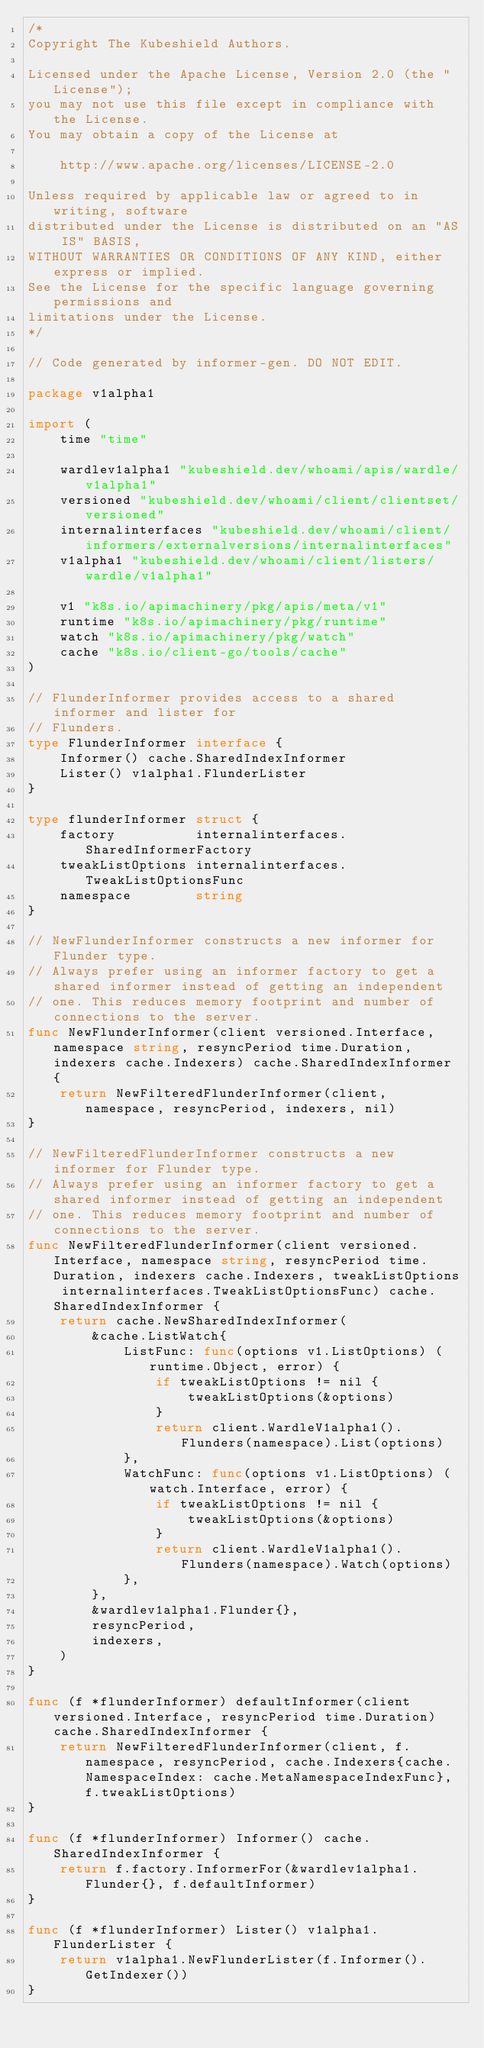<code> <loc_0><loc_0><loc_500><loc_500><_Go_>/*
Copyright The Kubeshield Authors.

Licensed under the Apache License, Version 2.0 (the "License");
you may not use this file except in compliance with the License.
You may obtain a copy of the License at

    http://www.apache.org/licenses/LICENSE-2.0

Unless required by applicable law or agreed to in writing, software
distributed under the License is distributed on an "AS IS" BASIS,
WITHOUT WARRANTIES OR CONDITIONS OF ANY KIND, either express or implied.
See the License for the specific language governing permissions and
limitations under the License.
*/

// Code generated by informer-gen. DO NOT EDIT.

package v1alpha1

import (
	time "time"

	wardlev1alpha1 "kubeshield.dev/whoami/apis/wardle/v1alpha1"
	versioned "kubeshield.dev/whoami/client/clientset/versioned"
	internalinterfaces "kubeshield.dev/whoami/client/informers/externalversions/internalinterfaces"
	v1alpha1 "kubeshield.dev/whoami/client/listers/wardle/v1alpha1"

	v1 "k8s.io/apimachinery/pkg/apis/meta/v1"
	runtime "k8s.io/apimachinery/pkg/runtime"
	watch "k8s.io/apimachinery/pkg/watch"
	cache "k8s.io/client-go/tools/cache"
)

// FlunderInformer provides access to a shared informer and lister for
// Flunders.
type FlunderInformer interface {
	Informer() cache.SharedIndexInformer
	Lister() v1alpha1.FlunderLister
}

type flunderInformer struct {
	factory          internalinterfaces.SharedInformerFactory
	tweakListOptions internalinterfaces.TweakListOptionsFunc
	namespace        string
}

// NewFlunderInformer constructs a new informer for Flunder type.
// Always prefer using an informer factory to get a shared informer instead of getting an independent
// one. This reduces memory footprint and number of connections to the server.
func NewFlunderInformer(client versioned.Interface, namespace string, resyncPeriod time.Duration, indexers cache.Indexers) cache.SharedIndexInformer {
	return NewFilteredFlunderInformer(client, namespace, resyncPeriod, indexers, nil)
}

// NewFilteredFlunderInformer constructs a new informer for Flunder type.
// Always prefer using an informer factory to get a shared informer instead of getting an independent
// one. This reduces memory footprint and number of connections to the server.
func NewFilteredFlunderInformer(client versioned.Interface, namespace string, resyncPeriod time.Duration, indexers cache.Indexers, tweakListOptions internalinterfaces.TweakListOptionsFunc) cache.SharedIndexInformer {
	return cache.NewSharedIndexInformer(
		&cache.ListWatch{
			ListFunc: func(options v1.ListOptions) (runtime.Object, error) {
				if tweakListOptions != nil {
					tweakListOptions(&options)
				}
				return client.WardleV1alpha1().Flunders(namespace).List(options)
			},
			WatchFunc: func(options v1.ListOptions) (watch.Interface, error) {
				if tweakListOptions != nil {
					tweakListOptions(&options)
				}
				return client.WardleV1alpha1().Flunders(namespace).Watch(options)
			},
		},
		&wardlev1alpha1.Flunder{},
		resyncPeriod,
		indexers,
	)
}

func (f *flunderInformer) defaultInformer(client versioned.Interface, resyncPeriod time.Duration) cache.SharedIndexInformer {
	return NewFilteredFlunderInformer(client, f.namespace, resyncPeriod, cache.Indexers{cache.NamespaceIndex: cache.MetaNamespaceIndexFunc}, f.tweakListOptions)
}

func (f *flunderInformer) Informer() cache.SharedIndexInformer {
	return f.factory.InformerFor(&wardlev1alpha1.Flunder{}, f.defaultInformer)
}

func (f *flunderInformer) Lister() v1alpha1.FlunderLister {
	return v1alpha1.NewFlunderLister(f.Informer().GetIndexer())
}
</code> 